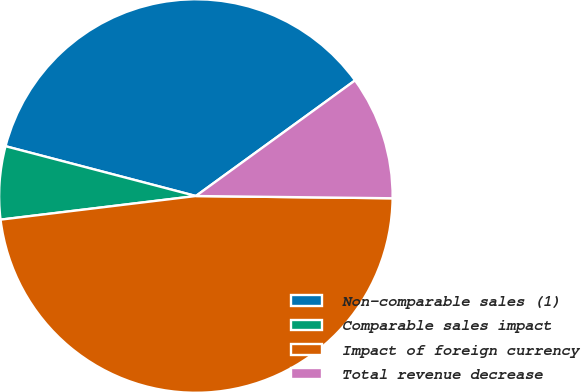Convert chart to OTSL. <chart><loc_0><loc_0><loc_500><loc_500><pie_chart><fcel>Non-comparable sales (1)<fcel>Comparable sales impact<fcel>Impact of foreign currency<fcel>Total revenue decrease<nl><fcel>35.93%<fcel>5.99%<fcel>47.9%<fcel>10.18%<nl></chart> 